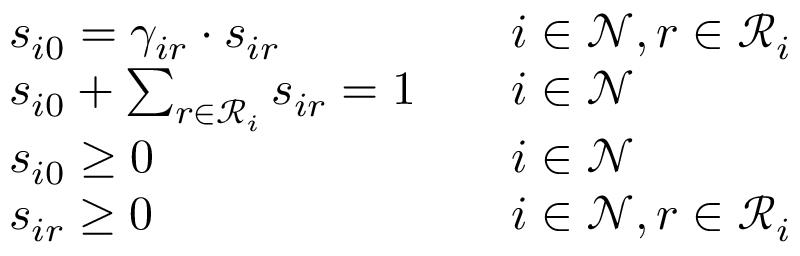<formula> <loc_0><loc_0><loc_500><loc_500>\begin{array} { r l r l } & { s _ { i 0 } = \gamma _ { i r } \cdot s _ { i r } } & & { i \in \mathcal { N } , r \in \mathcal { R } _ { i } } \\ & { s _ { i 0 } + \sum _ { r \in \mathcal { R } _ { i } } s _ { i r } = 1 } & & { i \in \mathcal { N } } \\ & { s _ { i 0 } \geq 0 } & & { i \in \mathcal { N } } \\ & { s _ { i r } \geq 0 } & & { i \in \mathcal { N } , r \in \mathcal { R } _ { i } } \end{array}</formula> 